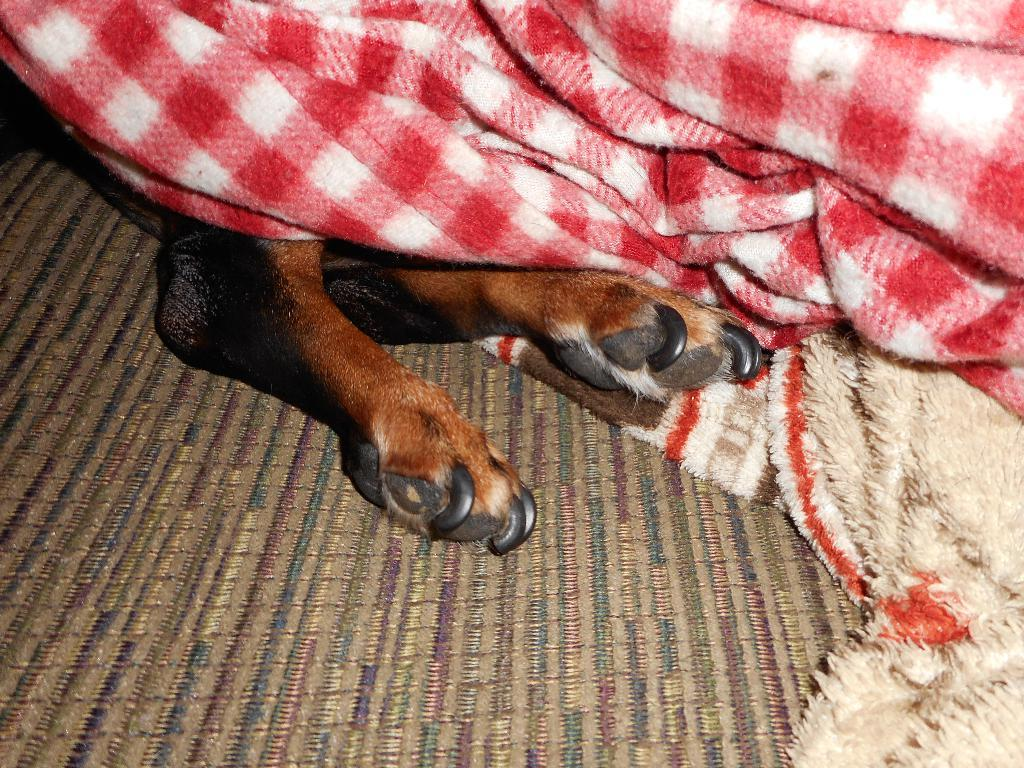What type of animal might the legs in the image belong to? The legs in the image might belong to an animal such as a dog or a cat. What items are present in the image that could be used for warmth or comfort? There are blankets and an object that looks like a mat in the image. What is the animal's tendency to participate in a minute-long competition in the image? There is no mention of a competition or a specific time duration in the image, and the animal's tendencies cannot be determined from the image alone. 